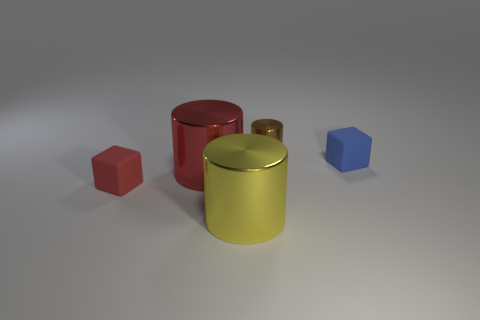Add 2 purple cubes. How many objects exist? 7 Subtract all blocks. How many objects are left? 3 Subtract all small cylinders. Subtract all large purple metallic balls. How many objects are left? 4 Add 1 yellow shiny cylinders. How many yellow shiny cylinders are left? 2 Add 5 blue things. How many blue things exist? 6 Subtract 0 brown cubes. How many objects are left? 5 